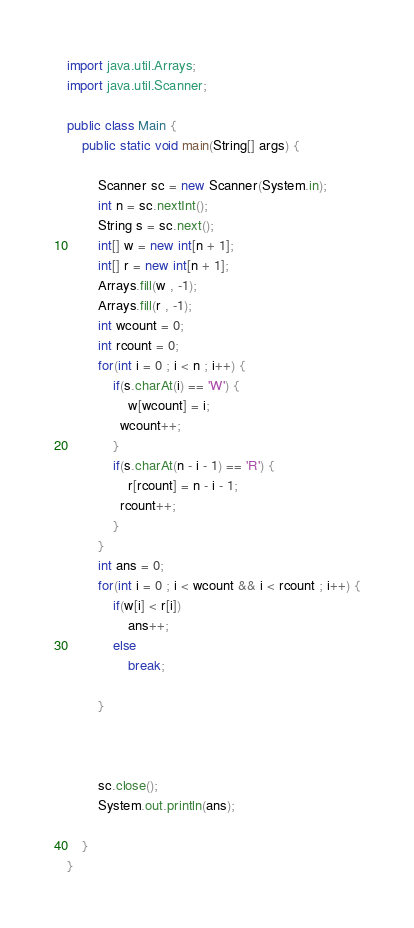Convert code to text. <code><loc_0><loc_0><loc_500><loc_500><_Java_>import java.util.Arrays;
import java.util.Scanner;

public class Main {
	public static void main(String[] args) {

		Scanner sc = new Scanner(System.in);
		int n = sc.nextInt();
		String s = sc.next();
		int[] w = new int[n + 1];
		int[] r = new int[n + 1];
		Arrays.fill(w , -1);
		Arrays.fill(r , -1);
		int wcount = 0;
		int rcount = 0;
		for(int i = 0 ; i < n ; i++) {
			if(s.charAt(i) == 'W') {
				w[wcount] = i;
              wcount++;
			}
			if(s.charAt(n - i - 1) == 'R') {
				r[rcount] = n - i - 1;
              rcount++;
			}
		}
		int ans = 0;
		for(int i = 0 ; i < wcount && i < rcount ; i++) {
			if(w[i] < r[i])
				ans++;
			else
				break;

		}



		sc.close();
		System.out.println(ans);

	}
}

</code> 